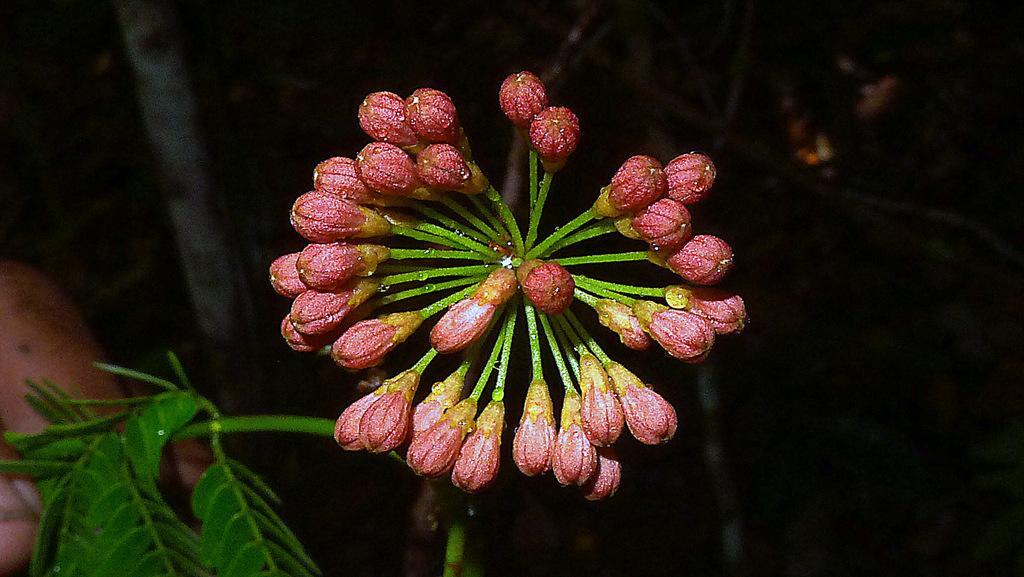In one or two sentences, can you explain what this image depicts? In this image I can see the flower to the plant. The flower is in pink and green color. And there is a black background. 